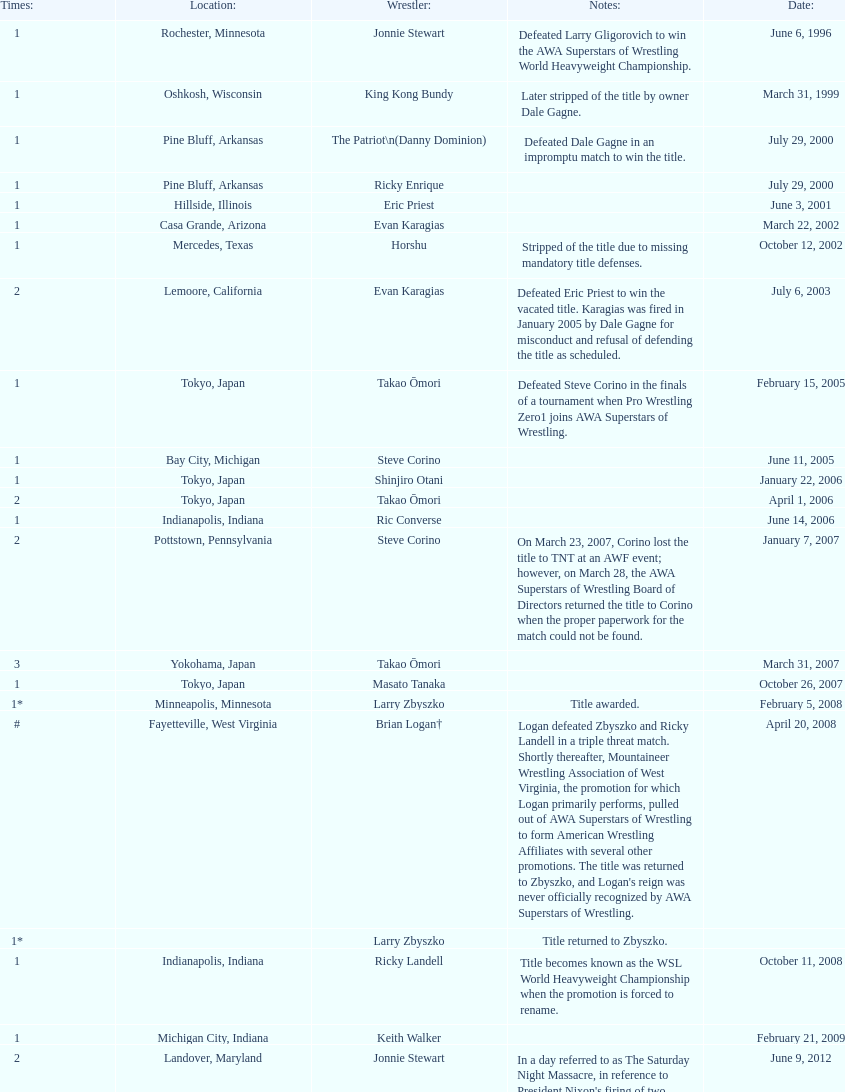How many different men held the wsl title before horshu won his first wsl title? 6. 